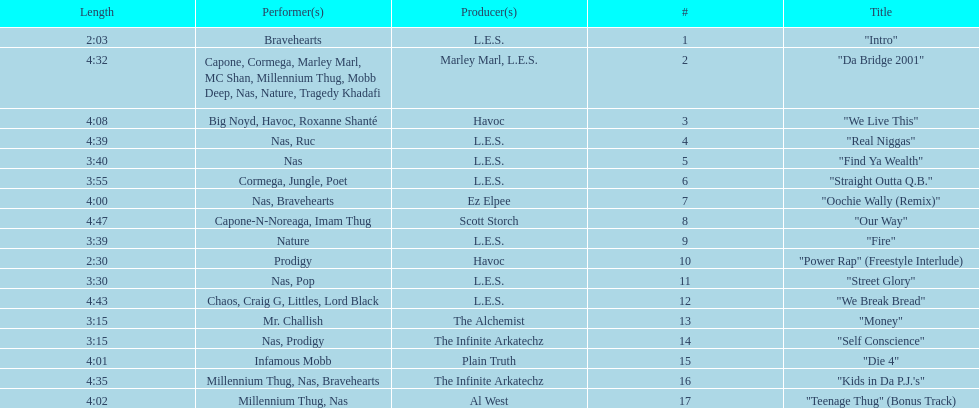What performers were in the last track? Millennium Thug, Nas. Parse the table in full. {'header': ['Length', 'Performer(s)', 'Producer(s)', '#', 'Title'], 'rows': [['2:03', 'Bravehearts', 'L.E.S.', '1', '"Intro"'], ['4:32', 'Capone, Cormega, Marley Marl, MC Shan, Millennium Thug, Mobb Deep, Nas, Nature, Tragedy Khadafi', 'Marley Marl, L.E.S.', '2', '"Da Bridge 2001"'], ['4:08', 'Big Noyd, Havoc, Roxanne Shanté', 'Havoc', '3', '"We Live This"'], ['4:39', 'Nas, Ruc', 'L.E.S.', '4', '"Real Niggas"'], ['3:40', 'Nas', 'L.E.S.', '5', '"Find Ya Wealth"'], ['3:55', 'Cormega, Jungle, Poet', 'L.E.S.', '6', '"Straight Outta Q.B."'], ['4:00', 'Nas, Bravehearts', 'Ez Elpee', '7', '"Oochie Wally (Remix)"'], ['4:47', 'Capone-N-Noreaga, Imam Thug', 'Scott Storch', '8', '"Our Way"'], ['3:39', 'Nature', 'L.E.S.', '9', '"Fire"'], ['2:30', 'Prodigy', 'Havoc', '10', '"Power Rap" (Freestyle Interlude)'], ['3:30', 'Nas, Pop', 'L.E.S.', '11', '"Street Glory"'], ['4:43', 'Chaos, Craig G, Littles, Lord Black', 'L.E.S.', '12', '"We Break Bread"'], ['3:15', 'Mr. Challish', 'The Alchemist', '13', '"Money"'], ['3:15', 'Nas, Prodigy', 'The Infinite Arkatechz', '14', '"Self Conscience"'], ['4:01', 'Infamous Mobb', 'Plain Truth', '15', '"Die 4"'], ['4:35', 'Millennium Thug, Nas, Bravehearts', 'The Infinite Arkatechz', '16', '"Kids in Da P.J.\'s"'], ['4:02', 'Millennium Thug, Nas', 'Al West', '17', '"Teenage Thug" (Bonus Track)']]} 